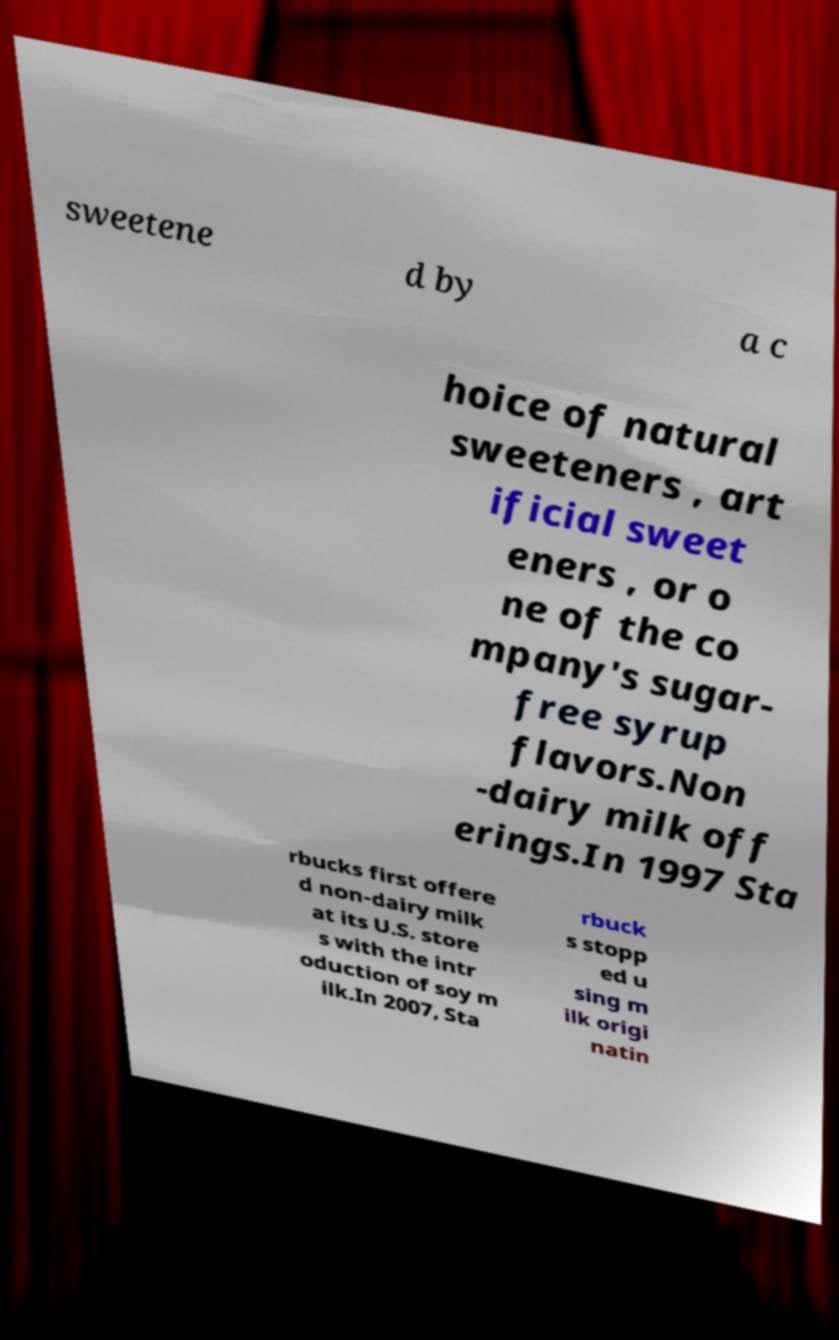Please read and relay the text visible in this image. What does it say? sweetene d by a c hoice of natural sweeteners , art ificial sweet eners , or o ne of the co mpany's sugar- free syrup flavors.Non -dairy milk off erings.In 1997 Sta rbucks first offere d non-dairy milk at its U.S. store s with the intr oduction of soy m ilk.In 2007, Sta rbuck s stopp ed u sing m ilk origi natin 